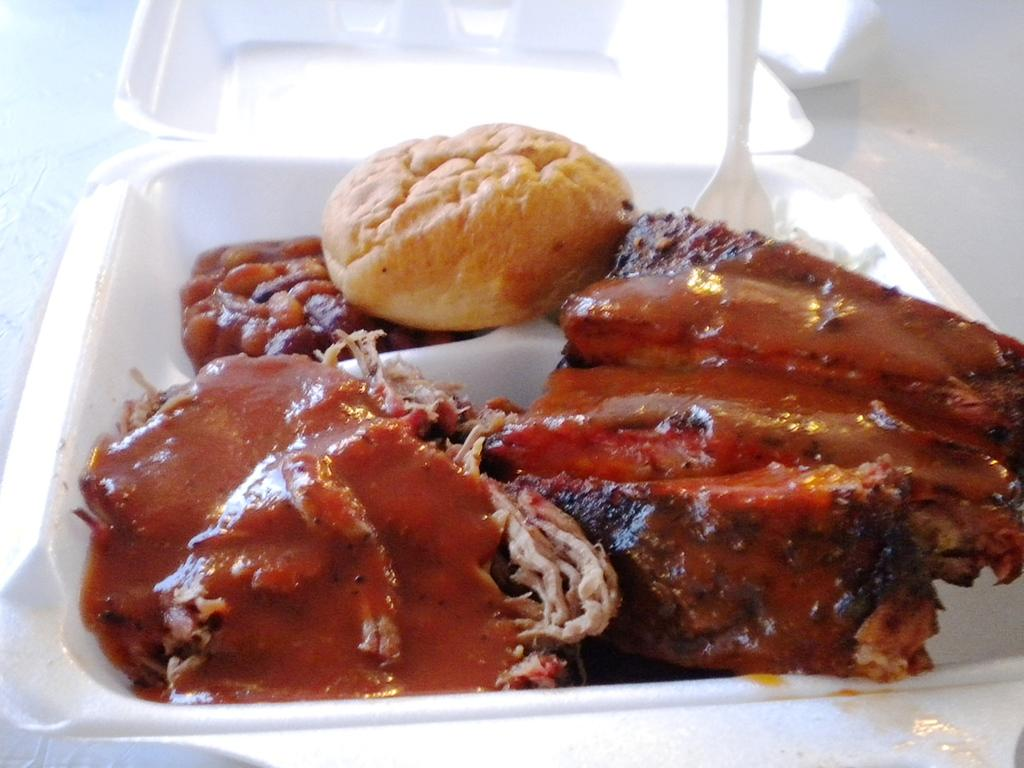What is present in the image related to food? There is food in the image. How is the food contained or stored? The food is in a container. What utensil can be seen in the image? There is a white spoon in the image. What type of train can be seen passing by the food in the image? There is no train present in the image; it only features food in a container and a white spoon. 